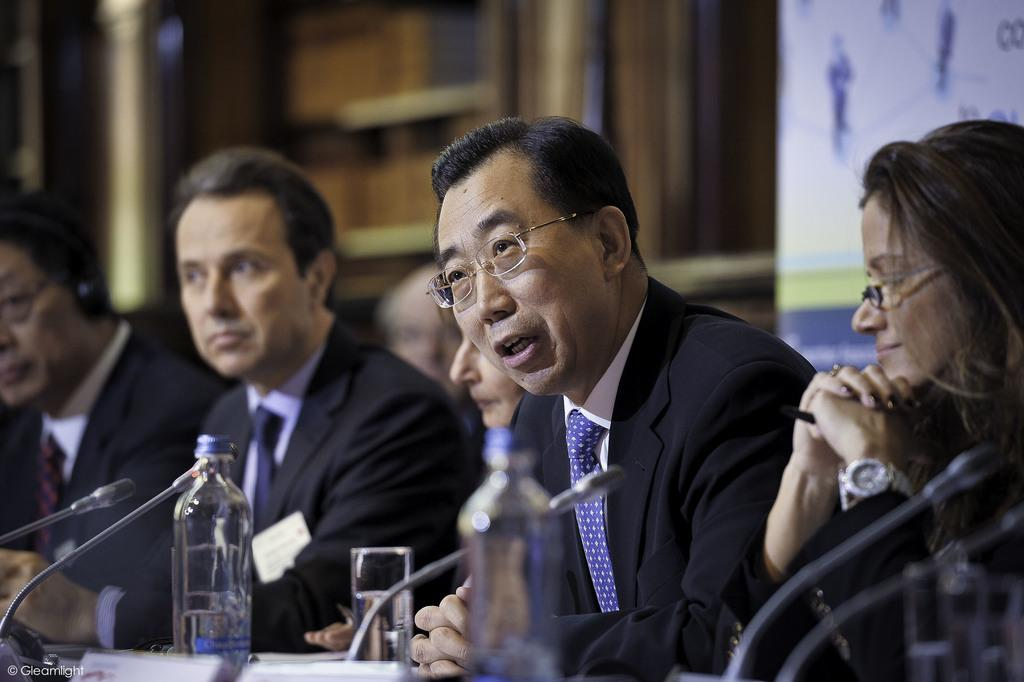What are the people in the image doing? The people in the image are sitting. What is the man with the microphone doing? The man is talking on a microphone. What else can be seen on the table in the image? There is a bottle and a glass on the table. What type of coal is being used to fuel the plough in the image? There is no plough or coal present in the image. What type of education is being provided in the image? The image does not depict any educational activities or settings. 